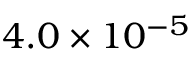<formula> <loc_0><loc_0><loc_500><loc_500>4 . 0 \times 1 0 ^ { - 5 }</formula> 